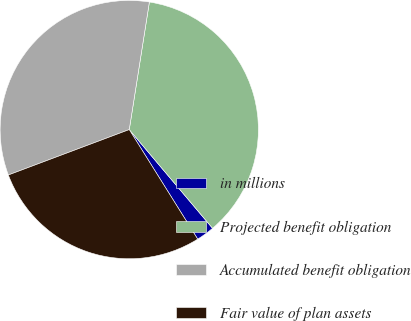Convert chart. <chart><loc_0><loc_0><loc_500><loc_500><pie_chart><fcel>in millions<fcel>Projected benefit obligation<fcel>Accumulated benefit obligation<fcel>Fair value of plan assets<nl><fcel>2.27%<fcel>36.35%<fcel>33.21%<fcel>28.17%<nl></chart> 